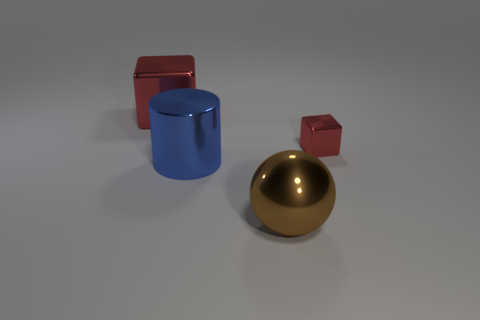Do the red metallic object that is on the left side of the small red thing and the blue shiny object have the same shape?
Your answer should be very brief. No. There is a object that is behind the small red metal object; what is its color?
Your response must be concise. Red. There is a large red thing that is the same material as the large brown thing; what is its shape?
Your answer should be very brief. Cube. Are there any other things that have the same color as the big shiny cylinder?
Provide a succinct answer. No. Is the number of large cylinders that are on the left side of the large blue cylinder greater than the number of small red cubes in front of the large brown sphere?
Provide a short and direct response. No. How many brown balls are the same size as the metallic cylinder?
Offer a terse response. 1. Is the number of tiny red metallic objects that are in front of the brown metallic ball less than the number of red metal objects to the right of the large cube?
Ensure brevity in your answer.  Yes. Are there any other tiny objects that have the same shape as the small thing?
Give a very brief answer. No. Is the shape of the small red thing the same as the big blue metallic object?
Your answer should be compact. No. What number of big things are blue matte cylinders or cubes?
Your answer should be very brief. 1. 